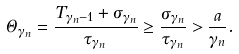<formula> <loc_0><loc_0><loc_500><loc_500>\Theta _ { \gamma _ { n } } = \frac { T _ { \gamma _ { n } - 1 } + \sigma _ { \gamma _ { n } } } { \tau _ { \gamma _ { n } } } \geq \frac { \sigma _ { \gamma _ { n } } } { \tau _ { \gamma _ { n } } } > \frac { a } { \gamma _ { n } } .</formula> 